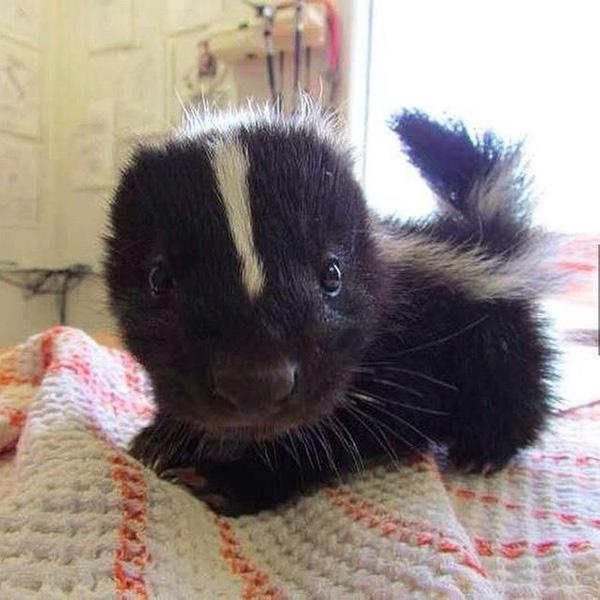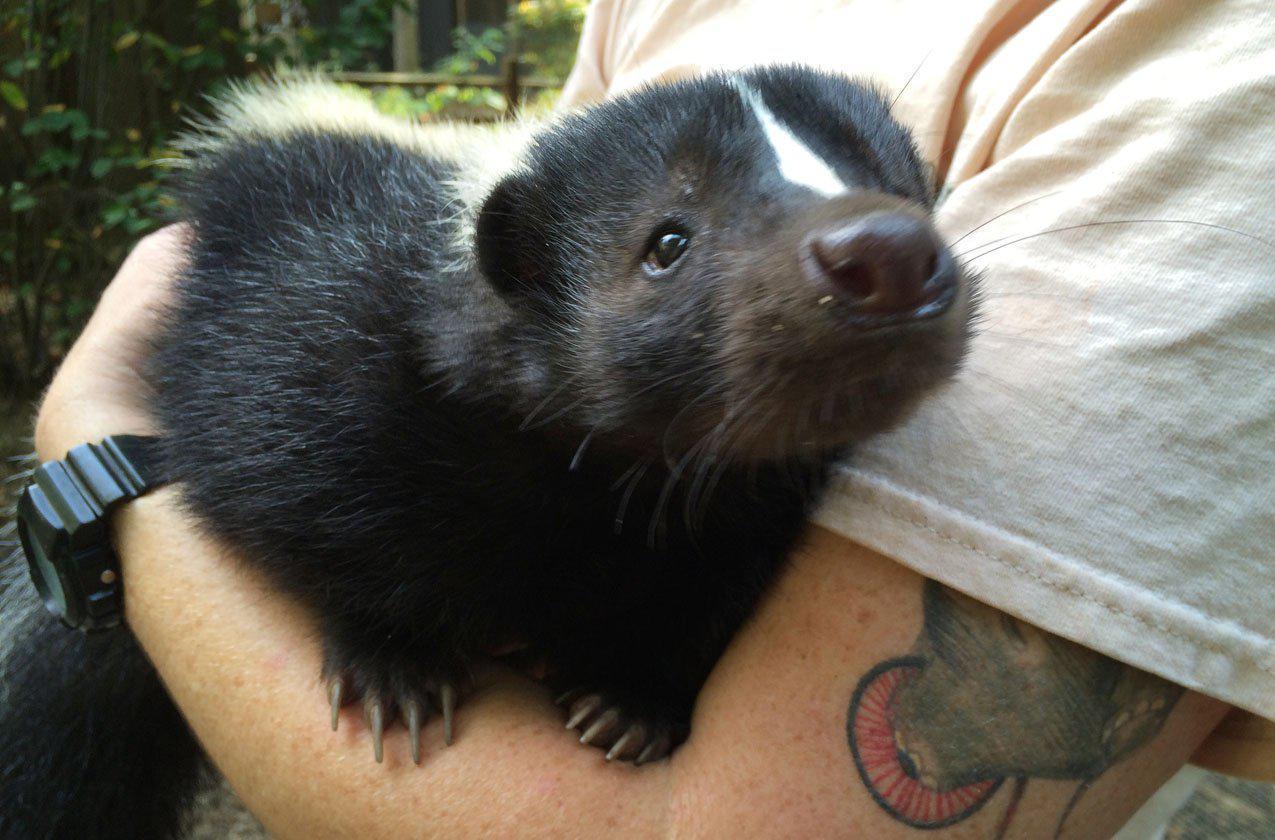The first image is the image on the left, the second image is the image on the right. For the images shown, is this caption "One image features a hand holding up a leftward-turned baby skunk, which is feeding from a syringe." true? Answer yes or no. No. The first image is the image on the left, the second image is the image on the right. Analyze the images presented: Is the assertion "The skunk in the right image is being bottle fed." valid? Answer yes or no. No. 